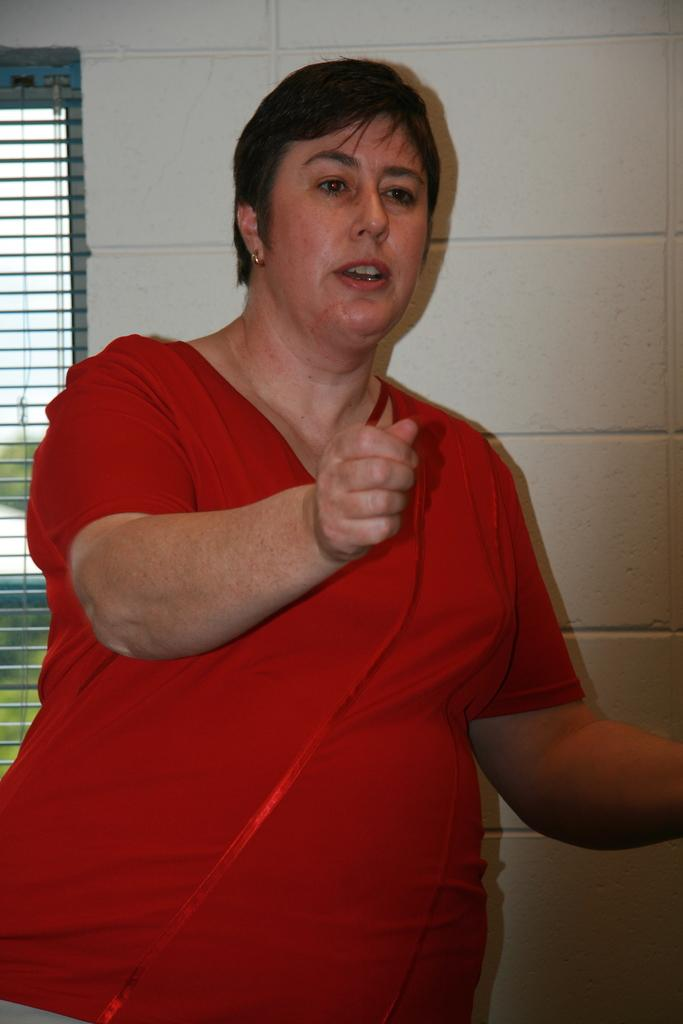What can be seen in the image? There is a person in the image. What is the person wearing? The person is wearing a red color T-shirt. Are there any accessories visible on the person? Yes, the person is wearing earrings. What is behind the person in the image? There is a wall behind the person. What can be seen in the background of the image? There is a window in the background. Can you see any pins on the person's clothing in the image? There is no mention of pins on the person's clothing in the provided facts, so we cannot determine if any are present. 